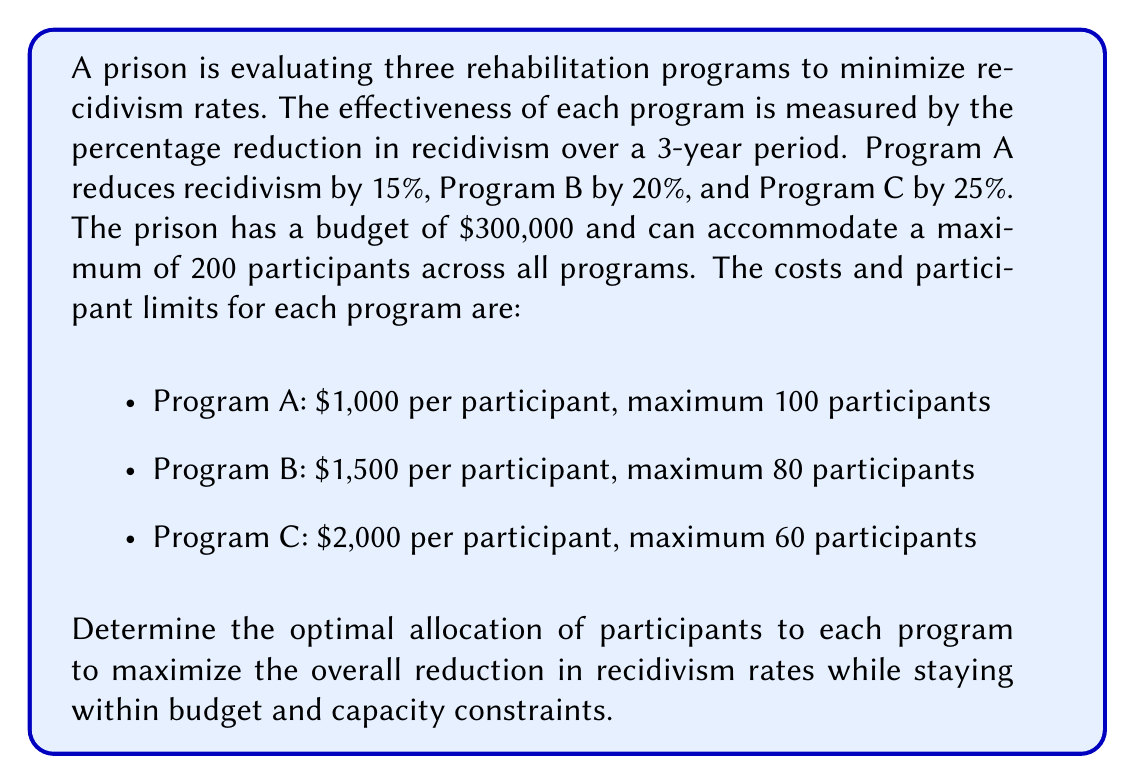Can you answer this question? To solve this optimization problem, we'll use linear programming. Let's define our variables:

$x_A$: number of participants in Program A
$x_B$: number of participants in Program B
$x_C$: number of participants in Program C

Our objective function is to maximize the total reduction in recidivism:

$$\text{Maximize } 0.15x_A + 0.20x_B + 0.25x_C$$

Subject to the following constraints:

1. Budget constraint: 
   $$1000x_A + 1500x_B + 2000x_C \leq 300000$$

2. Total participants constraint:
   $$x_A + x_B + x_C \leq 200$$

3. Individual program constraints:
   $$x_A \leq 100$$
   $$x_B \leq 80$$
   $$x_C \leq 60$$

4. Non-negativity constraints:
   $$x_A, x_B, x_C \geq 0$$

To solve this, we can use the simplex method or a linear programming solver. However, we can also reason through it:

1. Program C has the highest effectiveness, so we should maximize its participants first. We can accommodate 60 participants in Program C, using $120,000 of the budget.

2. Program B has the next highest effectiveness. With the remaining $180,000, we can accommodate 80 participants in Program B, using $120,000 more.

3. We've now used $240,000 of the budget and have 140 participants. We have $60,000 left and space for 60 more participants.

4. Program A is the least effective but also the cheapest. We can accommodate 60 more participants in Program A with the remaining budget.

This allocation satisfies all constraints and maximizes the overall reduction in recidivism.
Answer: The optimal allocation is:
- Program A: 60 participants
- Program B: 80 participants
- Program C: 60 participants

This results in a total of 200 participants and uses the full $300,000 budget. The expected overall reduction in recidivism is:

$$(0.15 \times 60) + (0.20 \times 80) + (0.25 \times 60) = 9 + 16 + 15 = 40\%$$ 